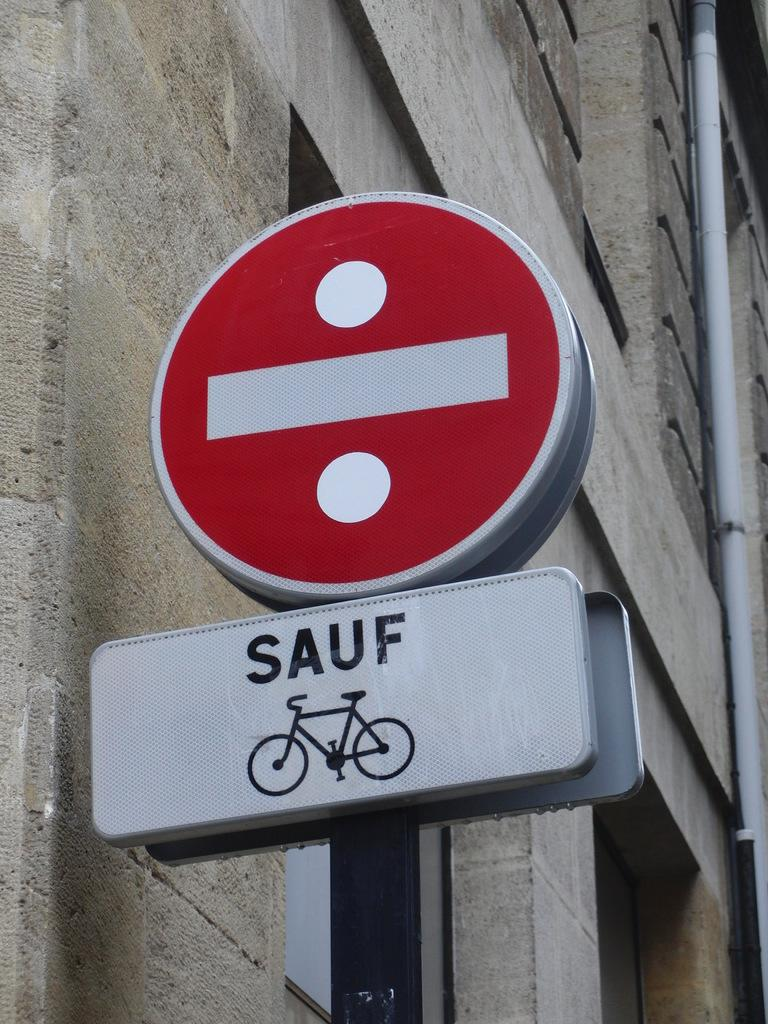<image>
Offer a succinct explanation of the picture presented. A do not enter sign says "sauf" bicycles, meaning they are exempt. 